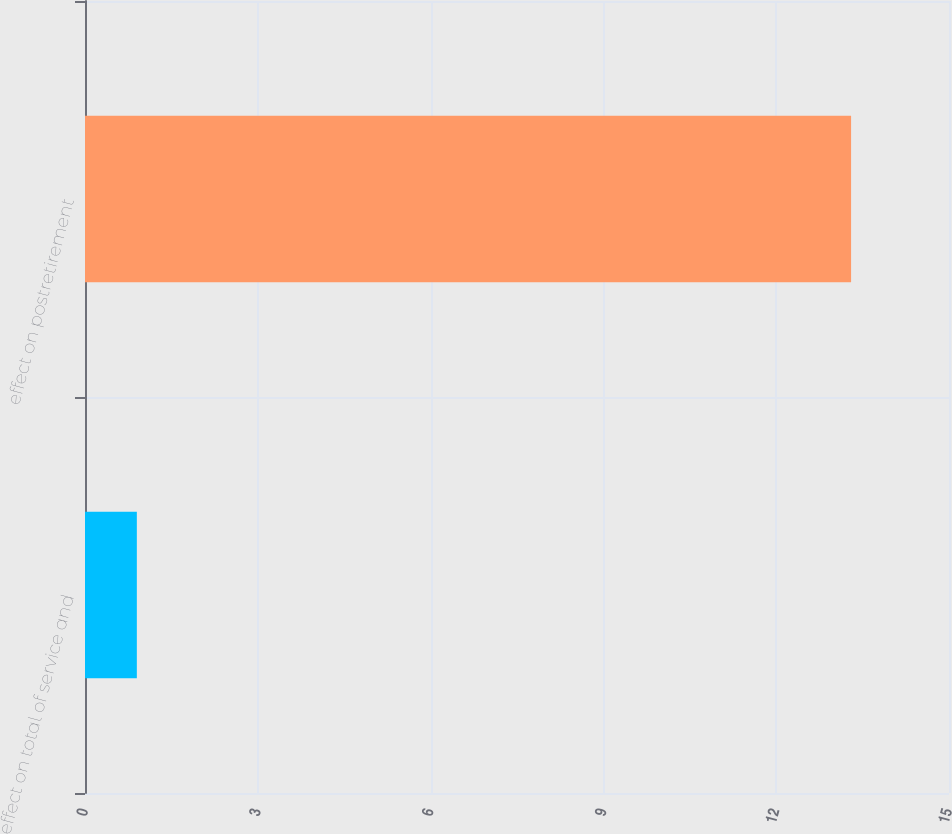<chart> <loc_0><loc_0><loc_500><loc_500><bar_chart><fcel>effect on total of service and<fcel>effect on postretirement<nl><fcel>0.9<fcel>13.3<nl></chart> 